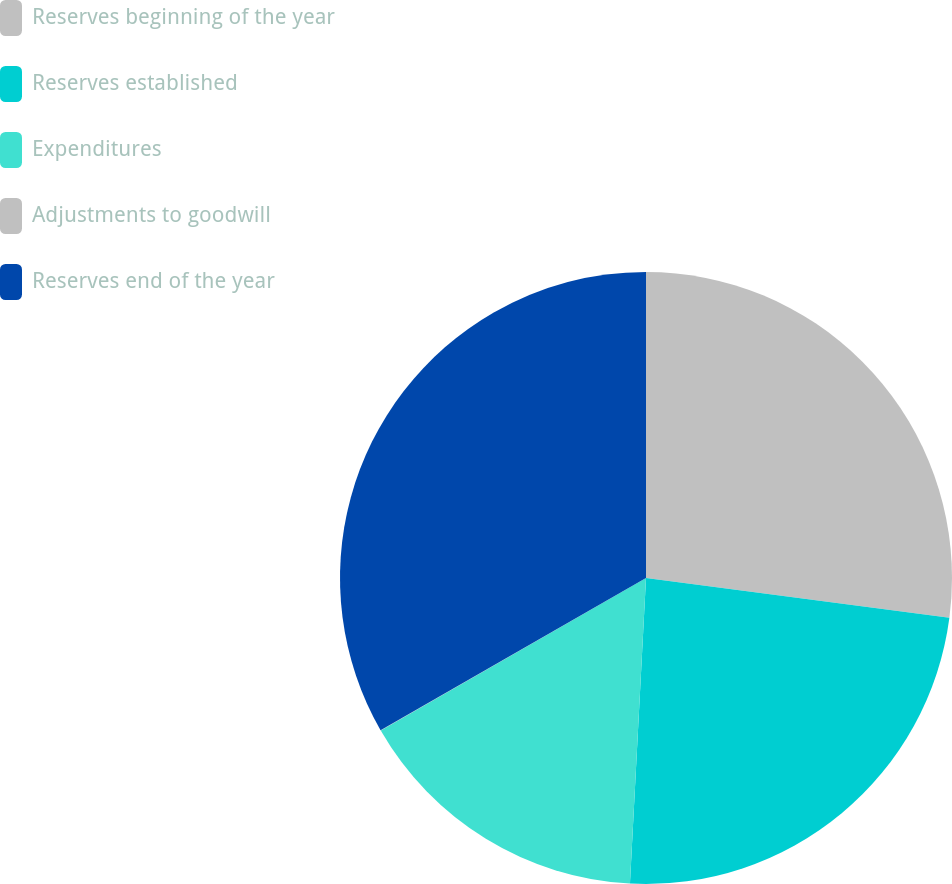Convert chart. <chart><loc_0><loc_0><loc_500><loc_500><pie_chart><fcel>Reserves beginning of the year<fcel>Reserves established<fcel>Expenditures<fcel>Adjustments to goodwill<fcel>Reserves end of the year<nl><fcel>27.08%<fcel>23.76%<fcel>15.86%<fcel>0.02%<fcel>33.29%<nl></chart> 